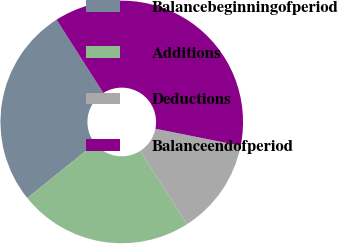Convert chart. <chart><loc_0><loc_0><loc_500><loc_500><pie_chart><fcel>Balancebeginningofperiod<fcel>Additions<fcel>Deductions<fcel>Balanceendofperiod<nl><fcel>26.76%<fcel>23.24%<fcel>12.82%<fcel>37.18%<nl></chart> 